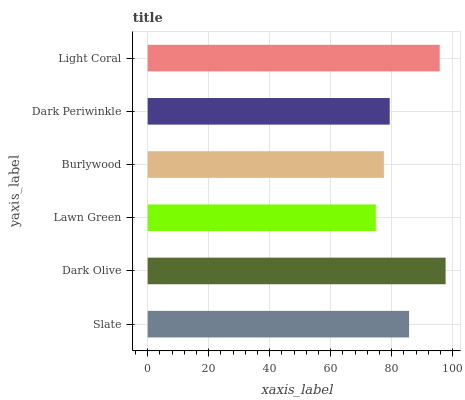Is Lawn Green the minimum?
Answer yes or no. Yes. Is Dark Olive the maximum?
Answer yes or no. Yes. Is Dark Olive the minimum?
Answer yes or no. No. Is Lawn Green the maximum?
Answer yes or no. No. Is Dark Olive greater than Lawn Green?
Answer yes or no. Yes. Is Lawn Green less than Dark Olive?
Answer yes or no. Yes. Is Lawn Green greater than Dark Olive?
Answer yes or no. No. Is Dark Olive less than Lawn Green?
Answer yes or no. No. Is Slate the high median?
Answer yes or no. Yes. Is Dark Periwinkle the low median?
Answer yes or no. Yes. Is Light Coral the high median?
Answer yes or no. No. Is Lawn Green the low median?
Answer yes or no. No. 